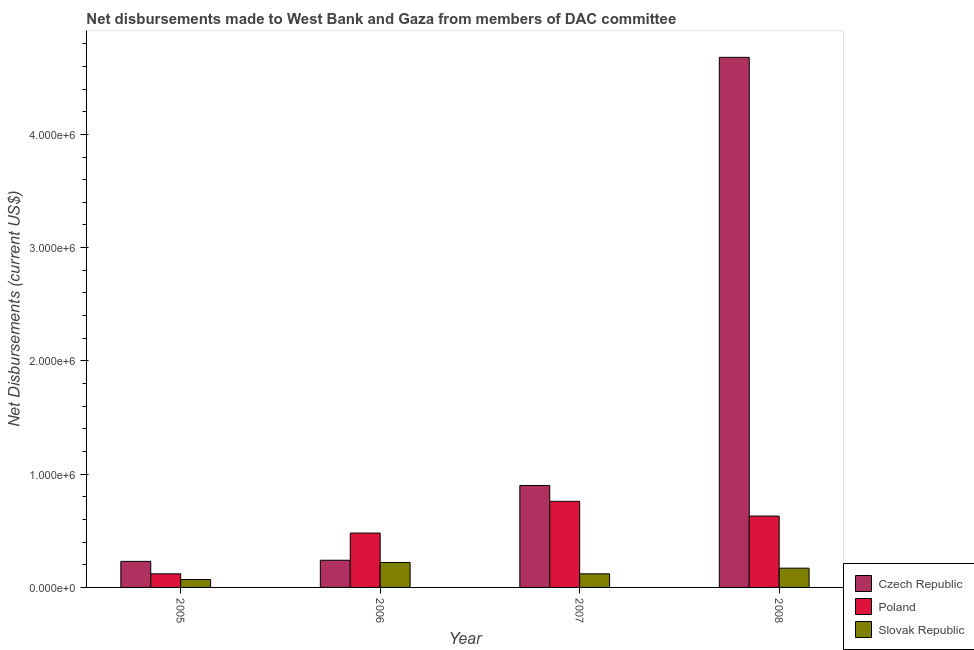How many different coloured bars are there?
Keep it short and to the point. 3. Are the number of bars on each tick of the X-axis equal?
Ensure brevity in your answer.  Yes. What is the label of the 3rd group of bars from the left?
Make the answer very short. 2007. What is the net disbursements made by poland in 2005?
Make the answer very short. 1.20e+05. Across all years, what is the maximum net disbursements made by poland?
Your answer should be compact. 7.60e+05. Across all years, what is the minimum net disbursements made by poland?
Keep it short and to the point. 1.20e+05. In which year was the net disbursements made by czech republic maximum?
Offer a very short reply. 2008. In which year was the net disbursements made by slovak republic minimum?
Offer a terse response. 2005. What is the total net disbursements made by slovak republic in the graph?
Provide a short and direct response. 5.80e+05. What is the difference between the net disbursements made by slovak republic in 2005 and that in 2007?
Make the answer very short. -5.00e+04. What is the difference between the net disbursements made by poland in 2008 and the net disbursements made by slovak republic in 2005?
Your response must be concise. 5.10e+05. What is the average net disbursements made by slovak republic per year?
Offer a very short reply. 1.45e+05. In the year 2008, what is the difference between the net disbursements made by poland and net disbursements made by czech republic?
Ensure brevity in your answer.  0. What is the ratio of the net disbursements made by slovak republic in 2006 to that in 2008?
Your answer should be compact. 1.29. What is the difference between the highest and the second highest net disbursements made by poland?
Your answer should be very brief. 1.30e+05. What is the difference between the highest and the lowest net disbursements made by poland?
Provide a succinct answer. 6.40e+05. What does the 3rd bar from the left in 2005 represents?
Offer a terse response. Slovak Republic. What does the 1st bar from the right in 2008 represents?
Offer a very short reply. Slovak Republic. Is it the case that in every year, the sum of the net disbursements made by czech republic and net disbursements made by poland is greater than the net disbursements made by slovak republic?
Your answer should be very brief. Yes. How many bars are there?
Offer a terse response. 12. Are all the bars in the graph horizontal?
Offer a terse response. No. What is the difference between two consecutive major ticks on the Y-axis?
Your answer should be very brief. 1.00e+06. Are the values on the major ticks of Y-axis written in scientific E-notation?
Your answer should be compact. Yes. Does the graph contain any zero values?
Your answer should be very brief. No. Does the graph contain grids?
Provide a short and direct response. No. Where does the legend appear in the graph?
Your answer should be compact. Bottom right. How many legend labels are there?
Ensure brevity in your answer.  3. How are the legend labels stacked?
Offer a terse response. Vertical. What is the title of the graph?
Your answer should be compact. Net disbursements made to West Bank and Gaza from members of DAC committee. What is the label or title of the X-axis?
Ensure brevity in your answer.  Year. What is the label or title of the Y-axis?
Your response must be concise. Net Disbursements (current US$). What is the Net Disbursements (current US$) in Slovak Republic in 2005?
Give a very brief answer. 7.00e+04. What is the Net Disbursements (current US$) of Poland in 2006?
Give a very brief answer. 4.80e+05. What is the Net Disbursements (current US$) of Czech Republic in 2007?
Make the answer very short. 9.00e+05. What is the Net Disbursements (current US$) in Poland in 2007?
Your response must be concise. 7.60e+05. What is the Net Disbursements (current US$) in Slovak Republic in 2007?
Provide a succinct answer. 1.20e+05. What is the Net Disbursements (current US$) in Czech Republic in 2008?
Offer a very short reply. 4.68e+06. What is the Net Disbursements (current US$) of Poland in 2008?
Your answer should be very brief. 6.30e+05. What is the Net Disbursements (current US$) in Slovak Republic in 2008?
Ensure brevity in your answer.  1.70e+05. Across all years, what is the maximum Net Disbursements (current US$) in Czech Republic?
Provide a succinct answer. 4.68e+06. Across all years, what is the maximum Net Disbursements (current US$) of Poland?
Provide a succinct answer. 7.60e+05. Across all years, what is the minimum Net Disbursements (current US$) of Czech Republic?
Your answer should be compact. 2.30e+05. Across all years, what is the minimum Net Disbursements (current US$) in Poland?
Your answer should be very brief. 1.20e+05. Across all years, what is the minimum Net Disbursements (current US$) in Slovak Republic?
Provide a short and direct response. 7.00e+04. What is the total Net Disbursements (current US$) of Czech Republic in the graph?
Keep it short and to the point. 6.05e+06. What is the total Net Disbursements (current US$) in Poland in the graph?
Provide a succinct answer. 1.99e+06. What is the total Net Disbursements (current US$) of Slovak Republic in the graph?
Your response must be concise. 5.80e+05. What is the difference between the Net Disbursements (current US$) of Poland in 2005 and that in 2006?
Your answer should be compact. -3.60e+05. What is the difference between the Net Disbursements (current US$) of Slovak Republic in 2005 and that in 2006?
Give a very brief answer. -1.50e+05. What is the difference between the Net Disbursements (current US$) in Czech Republic in 2005 and that in 2007?
Offer a very short reply. -6.70e+05. What is the difference between the Net Disbursements (current US$) in Poland in 2005 and that in 2007?
Ensure brevity in your answer.  -6.40e+05. What is the difference between the Net Disbursements (current US$) in Slovak Republic in 2005 and that in 2007?
Make the answer very short. -5.00e+04. What is the difference between the Net Disbursements (current US$) in Czech Republic in 2005 and that in 2008?
Your response must be concise. -4.45e+06. What is the difference between the Net Disbursements (current US$) of Poland in 2005 and that in 2008?
Keep it short and to the point. -5.10e+05. What is the difference between the Net Disbursements (current US$) in Czech Republic in 2006 and that in 2007?
Keep it short and to the point. -6.60e+05. What is the difference between the Net Disbursements (current US$) of Poland in 2006 and that in 2007?
Ensure brevity in your answer.  -2.80e+05. What is the difference between the Net Disbursements (current US$) in Slovak Republic in 2006 and that in 2007?
Your answer should be very brief. 1.00e+05. What is the difference between the Net Disbursements (current US$) in Czech Republic in 2006 and that in 2008?
Offer a very short reply. -4.44e+06. What is the difference between the Net Disbursements (current US$) of Poland in 2006 and that in 2008?
Your answer should be very brief. -1.50e+05. What is the difference between the Net Disbursements (current US$) in Slovak Republic in 2006 and that in 2008?
Offer a very short reply. 5.00e+04. What is the difference between the Net Disbursements (current US$) of Czech Republic in 2007 and that in 2008?
Your answer should be compact. -3.78e+06. What is the difference between the Net Disbursements (current US$) of Poland in 2007 and that in 2008?
Your response must be concise. 1.30e+05. What is the difference between the Net Disbursements (current US$) in Czech Republic in 2005 and the Net Disbursements (current US$) in Poland in 2006?
Provide a succinct answer. -2.50e+05. What is the difference between the Net Disbursements (current US$) in Czech Republic in 2005 and the Net Disbursements (current US$) in Poland in 2007?
Provide a short and direct response. -5.30e+05. What is the difference between the Net Disbursements (current US$) in Poland in 2005 and the Net Disbursements (current US$) in Slovak Republic in 2007?
Make the answer very short. 0. What is the difference between the Net Disbursements (current US$) of Czech Republic in 2005 and the Net Disbursements (current US$) of Poland in 2008?
Provide a short and direct response. -4.00e+05. What is the difference between the Net Disbursements (current US$) in Poland in 2005 and the Net Disbursements (current US$) in Slovak Republic in 2008?
Provide a short and direct response. -5.00e+04. What is the difference between the Net Disbursements (current US$) in Czech Republic in 2006 and the Net Disbursements (current US$) in Poland in 2007?
Offer a very short reply. -5.20e+05. What is the difference between the Net Disbursements (current US$) in Czech Republic in 2006 and the Net Disbursements (current US$) in Slovak Republic in 2007?
Give a very brief answer. 1.20e+05. What is the difference between the Net Disbursements (current US$) in Czech Republic in 2006 and the Net Disbursements (current US$) in Poland in 2008?
Your answer should be very brief. -3.90e+05. What is the difference between the Net Disbursements (current US$) of Czech Republic in 2006 and the Net Disbursements (current US$) of Slovak Republic in 2008?
Provide a short and direct response. 7.00e+04. What is the difference between the Net Disbursements (current US$) of Czech Republic in 2007 and the Net Disbursements (current US$) of Poland in 2008?
Offer a terse response. 2.70e+05. What is the difference between the Net Disbursements (current US$) in Czech Republic in 2007 and the Net Disbursements (current US$) in Slovak Republic in 2008?
Keep it short and to the point. 7.30e+05. What is the difference between the Net Disbursements (current US$) of Poland in 2007 and the Net Disbursements (current US$) of Slovak Republic in 2008?
Keep it short and to the point. 5.90e+05. What is the average Net Disbursements (current US$) in Czech Republic per year?
Provide a succinct answer. 1.51e+06. What is the average Net Disbursements (current US$) in Poland per year?
Give a very brief answer. 4.98e+05. What is the average Net Disbursements (current US$) of Slovak Republic per year?
Offer a very short reply. 1.45e+05. In the year 2005, what is the difference between the Net Disbursements (current US$) in Czech Republic and Net Disbursements (current US$) in Poland?
Your answer should be very brief. 1.10e+05. In the year 2006, what is the difference between the Net Disbursements (current US$) of Czech Republic and Net Disbursements (current US$) of Poland?
Your answer should be very brief. -2.40e+05. In the year 2006, what is the difference between the Net Disbursements (current US$) of Czech Republic and Net Disbursements (current US$) of Slovak Republic?
Your answer should be very brief. 2.00e+04. In the year 2007, what is the difference between the Net Disbursements (current US$) in Czech Republic and Net Disbursements (current US$) in Slovak Republic?
Your answer should be very brief. 7.80e+05. In the year 2007, what is the difference between the Net Disbursements (current US$) in Poland and Net Disbursements (current US$) in Slovak Republic?
Ensure brevity in your answer.  6.40e+05. In the year 2008, what is the difference between the Net Disbursements (current US$) of Czech Republic and Net Disbursements (current US$) of Poland?
Your answer should be compact. 4.05e+06. In the year 2008, what is the difference between the Net Disbursements (current US$) in Czech Republic and Net Disbursements (current US$) in Slovak Republic?
Make the answer very short. 4.51e+06. In the year 2008, what is the difference between the Net Disbursements (current US$) of Poland and Net Disbursements (current US$) of Slovak Republic?
Provide a short and direct response. 4.60e+05. What is the ratio of the Net Disbursements (current US$) of Slovak Republic in 2005 to that in 2006?
Offer a terse response. 0.32. What is the ratio of the Net Disbursements (current US$) in Czech Republic in 2005 to that in 2007?
Make the answer very short. 0.26. What is the ratio of the Net Disbursements (current US$) of Poland in 2005 to that in 2007?
Your answer should be very brief. 0.16. What is the ratio of the Net Disbursements (current US$) in Slovak Republic in 2005 to that in 2007?
Offer a terse response. 0.58. What is the ratio of the Net Disbursements (current US$) of Czech Republic in 2005 to that in 2008?
Give a very brief answer. 0.05. What is the ratio of the Net Disbursements (current US$) in Poland in 2005 to that in 2008?
Your response must be concise. 0.19. What is the ratio of the Net Disbursements (current US$) in Slovak Republic in 2005 to that in 2008?
Your answer should be very brief. 0.41. What is the ratio of the Net Disbursements (current US$) in Czech Republic in 2006 to that in 2007?
Offer a terse response. 0.27. What is the ratio of the Net Disbursements (current US$) in Poland in 2006 to that in 2007?
Give a very brief answer. 0.63. What is the ratio of the Net Disbursements (current US$) of Slovak Republic in 2006 to that in 2007?
Offer a terse response. 1.83. What is the ratio of the Net Disbursements (current US$) in Czech Republic in 2006 to that in 2008?
Provide a succinct answer. 0.05. What is the ratio of the Net Disbursements (current US$) of Poland in 2006 to that in 2008?
Offer a terse response. 0.76. What is the ratio of the Net Disbursements (current US$) in Slovak Republic in 2006 to that in 2008?
Ensure brevity in your answer.  1.29. What is the ratio of the Net Disbursements (current US$) of Czech Republic in 2007 to that in 2008?
Provide a succinct answer. 0.19. What is the ratio of the Net Disbursements (current US$) of Poland in 2007 to that in 2008?
Your answer should be very brief. 1.21. What is the ratio of the Net Disbursements (current US$) in Slovak Republic in 2007 to that in 2008?
Provide a short and direct response. 0.71. What is the difference between the highest and the second highest Net Disbursements (current US$) in Czech Republic?
Offer a terse response. 3.78e+06. What is the difference between the highest and the lowest Net Disbursements (current US$) of Czech Republic?
Your answer should be compact. 4.45e+06. What is the difference between the highest and the lowest Net Disbursements (current US$) in Poland?
Your response must be concise. 6.40e+05. What is the difference between the highest and the lowest Net Disbursements (current US$) of Slovak Republic?
Your answer should be compact. 1.50e+05. 